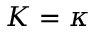Convert formula to latex. <formula><loc_0><loc_0><loc_500><loc_500>K = \kappa</formula> 